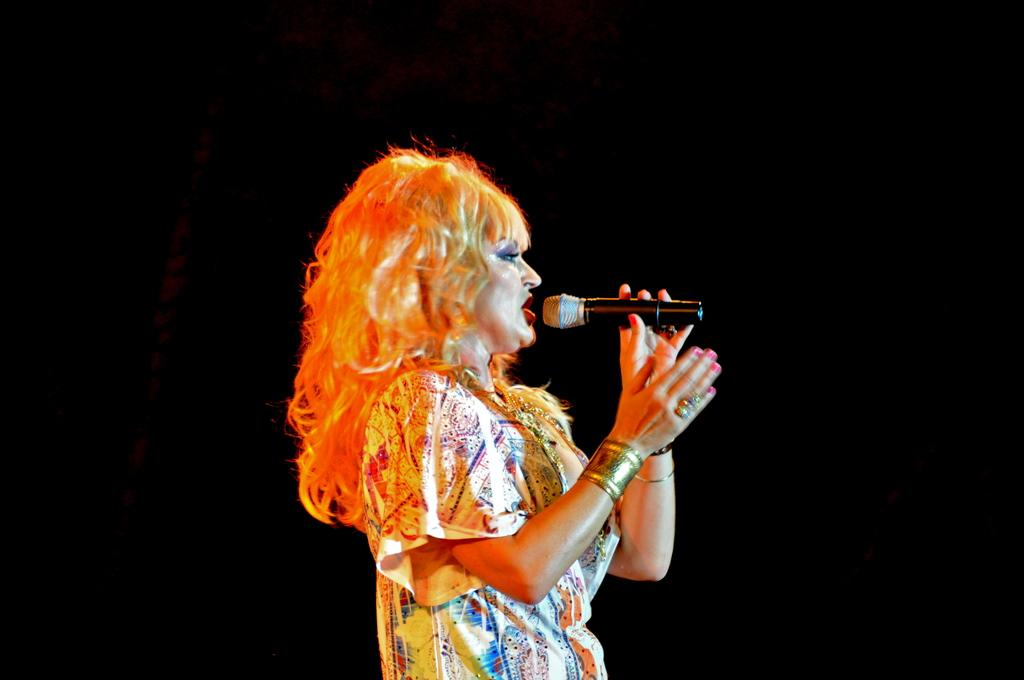Who is the main subject in the image? There is a woman in the image. What is the woman holding in the image? The woman is holding a microphone. What is the woman doing in the image? The woman is singing. What is the color of the background in the image? The background of the image is black. Can you see a man in the image? No, there is no man present in the image; it features a woman. Is the woman embarking on a voyage in the image? No, there is no indication of a voyage in the image; the woman is singing with a microphone. 